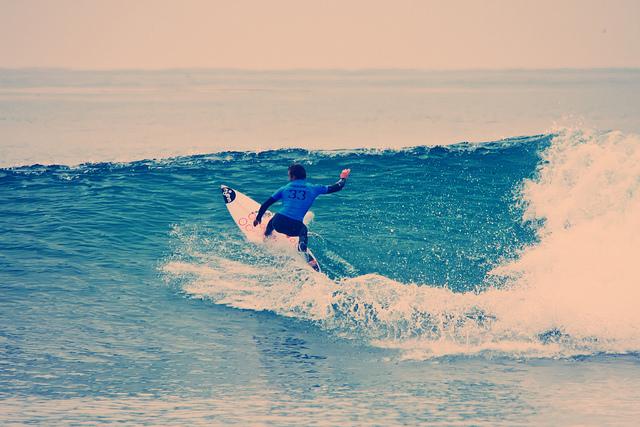What color is the surfer's shirt?
Keep it brief. Blue. How many people are in the water?
Write a very short answer. 1. How are the waves?
Write a very short answer. Fair. What color is his shirt?
Concise answer only. Blue. What are the people holding?
Keep it brief. Nothing. What is this person doing?
Answer briefly. Surfing. Is the water placid?
Be succinct. No. What color is the water?
Concise answer only. Blue. What is the man doing?
Quick response, please. Surfing. Is the man wearing a shirt?
Short answer required. Yes. 